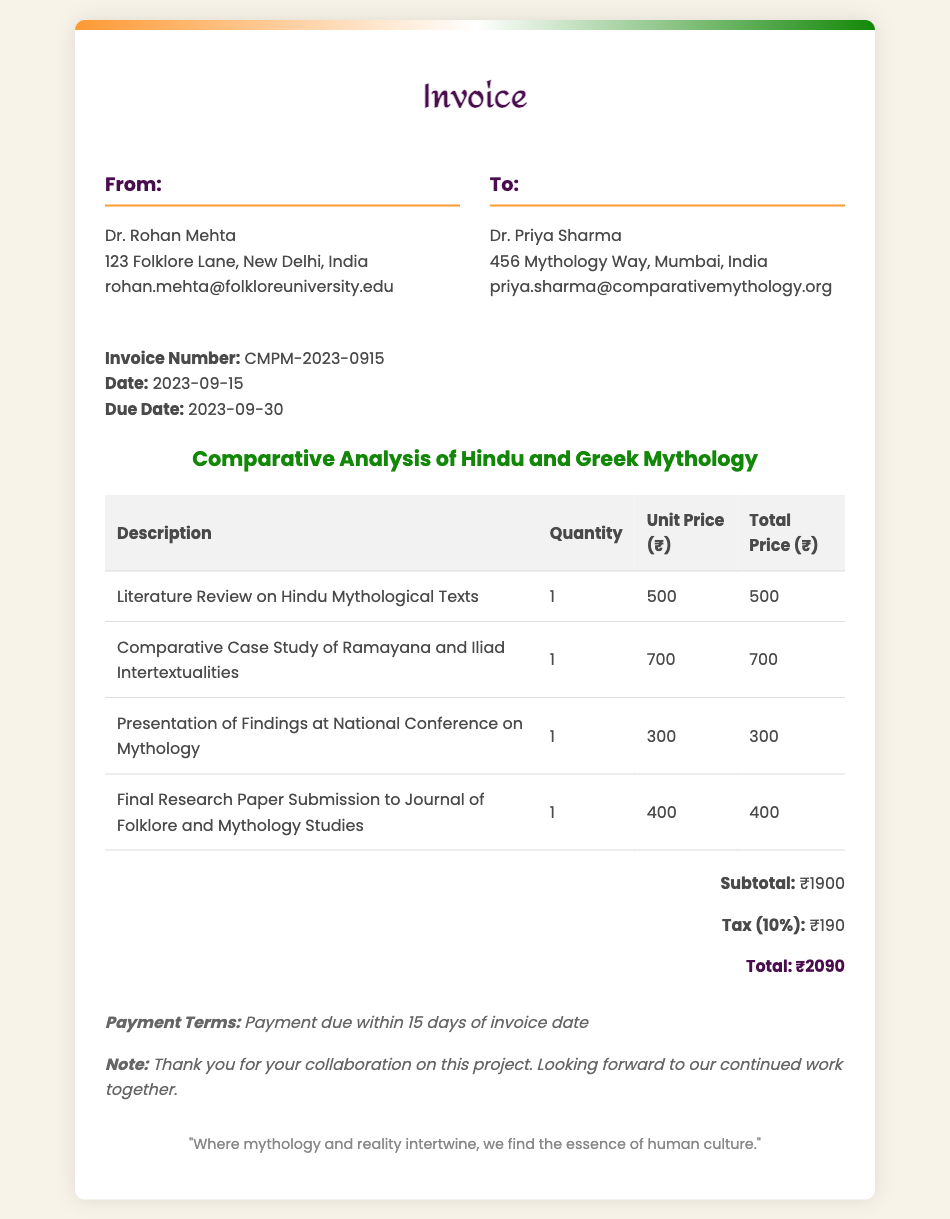What is the invoice number? The invoice number is specified in the document under the invoice details section.
Answer: CMPM-2023-0915 What is the due date for the invoice? The due date is stated explicitly in the document as the deadline for payment.
Answer: 2023-09-30 Who is the recipient of the invoice? The recipient’s name is listed under the "To" section of the header.
Answer: Dr. Priya Sharma What is the total amount due? The total amount is calculated and presented at the bottom of the document.
Answer: ₹2090 What is the subtotal before tax? The subtotal is shown in the total section, before the addition of tax.
Answer: ₹1900 How much is the tax charged? The tax amount is listed separately in the total section of the document.
Answer: ₹190 What is the project title? The project title is highlighted in the document, referring to the subject of the invoice.
Answer: Comparative Analysis of Hindu and Greek Mythology How many deliverables are listed in the invoice? The number of deliverables can be counted from the items listed in the table.
Answer: 4 What is the payment term? The payment terms are mentioned within the notes section of the invoice.
Answer: Payment due within 15 days of invoice date What is the first deliverable listed? The first deliverable is the initial entry in the table of the invoice.
Answer: Literature Review on Hindu Mythological Texts 